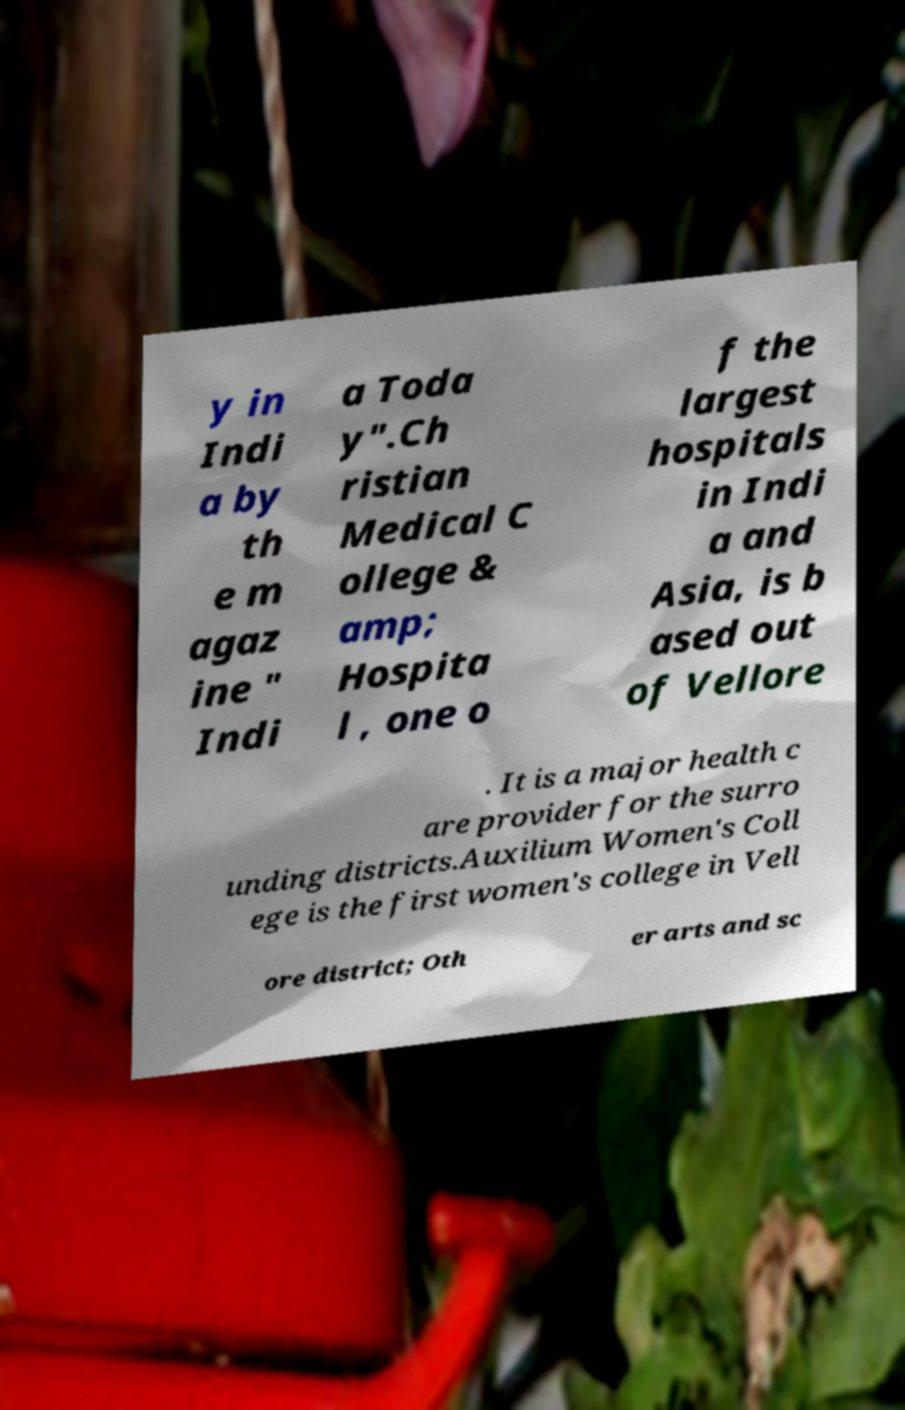Can you accurately transcribe the text from the provided image for me? y in Indi a by th e m agaz ine " Indi a Toda y".Ch ristian Medical C ollege & amp; Hospita l , one o f the largest hospitals in Indi a and Asia, is b ased out of Vellore . It is a major health c are provider for the surro unding districts.Auxilium Women's Coll ege is the first women's college in Vell ore district; Oth er arts and sc 